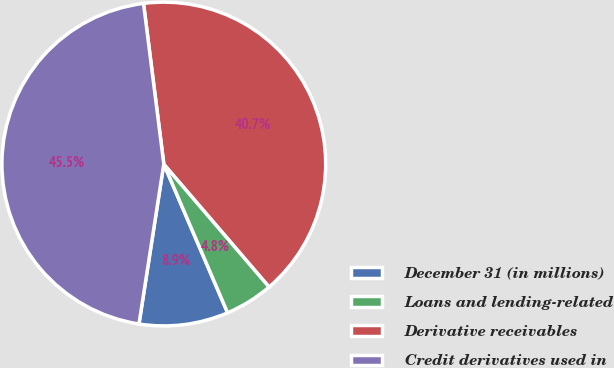Convert chart. <chart><loc_0><loc_0><loc_500><loc_500><pie_chart><fcel>December 31 (in millions)<fcel>Loans and lending-related<fcel>Derivative receivables<fcel>Credit derivatives used in<nl><fcel>8.9%<fcel>4.83%<fcel>40.72%<fcel>45.55%<nl></chart> 